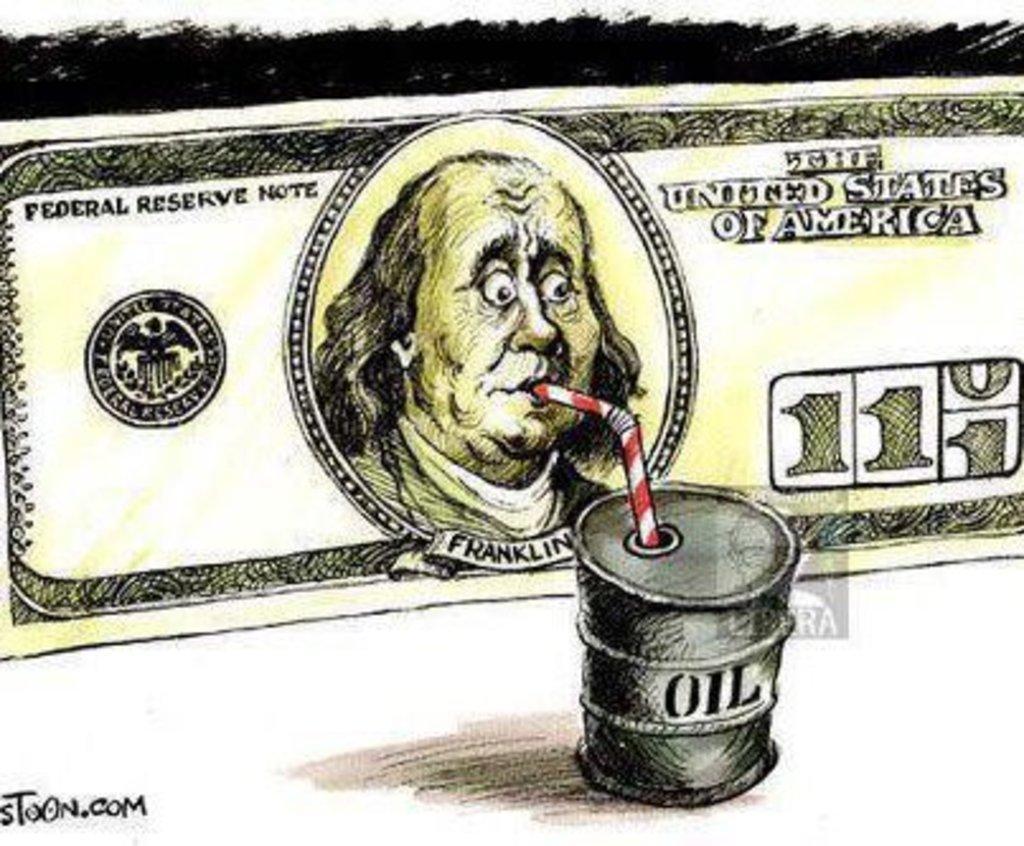How would you summarize this image in a sentence or two? This is a painted picture. We see a dollar and oil tank and a straw and we see text on the corner. 